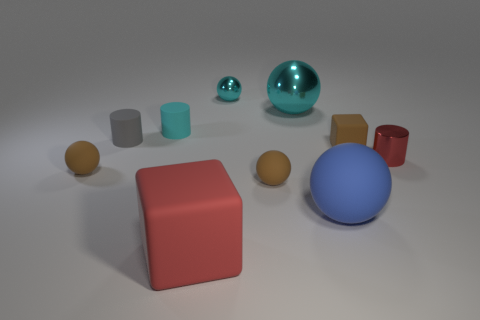What color is the big matte thing that is left of the large blue ball? The large matte object to the left of the large blue ball is a red block. 